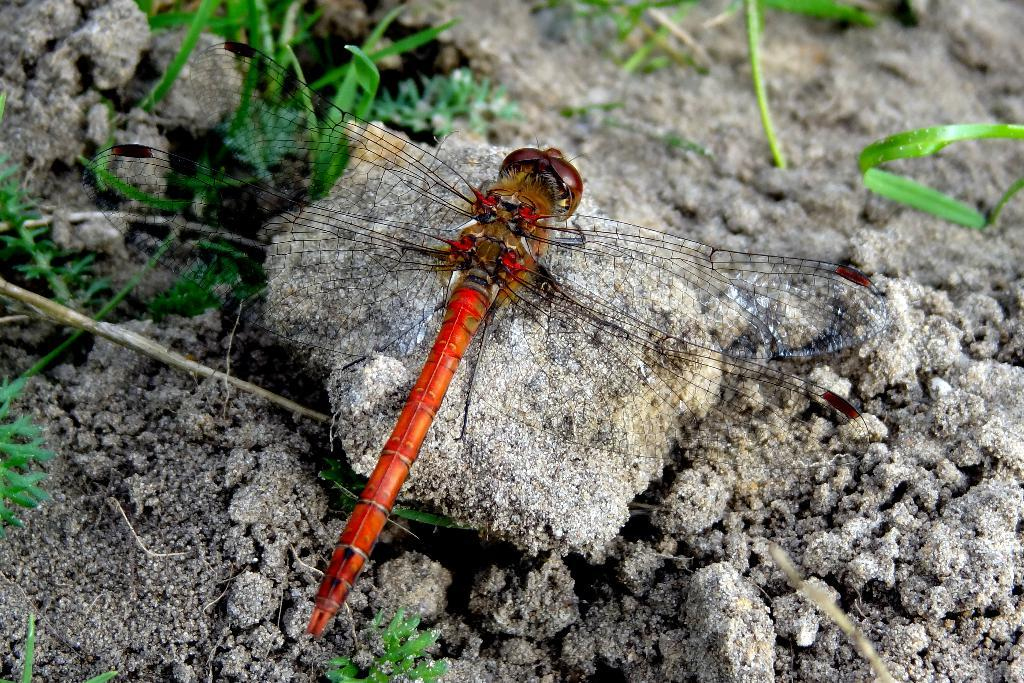What insect can be seen in the picture? There is a dragonfly in the picture. What is the color of the dragonfly? The dragonfly is red in color. What type of surface is visible in the picture? Soil is visible in the picture. What type of plants can be seen in the picture? There are herbs in the picture. How would you describe the background of the image? The background of the image is blurred. Is there a cushion in the picture that the dragonfly is sitting on? No, there is no cushion present in the image. The dragonfly is flying above the soil and herbs. 